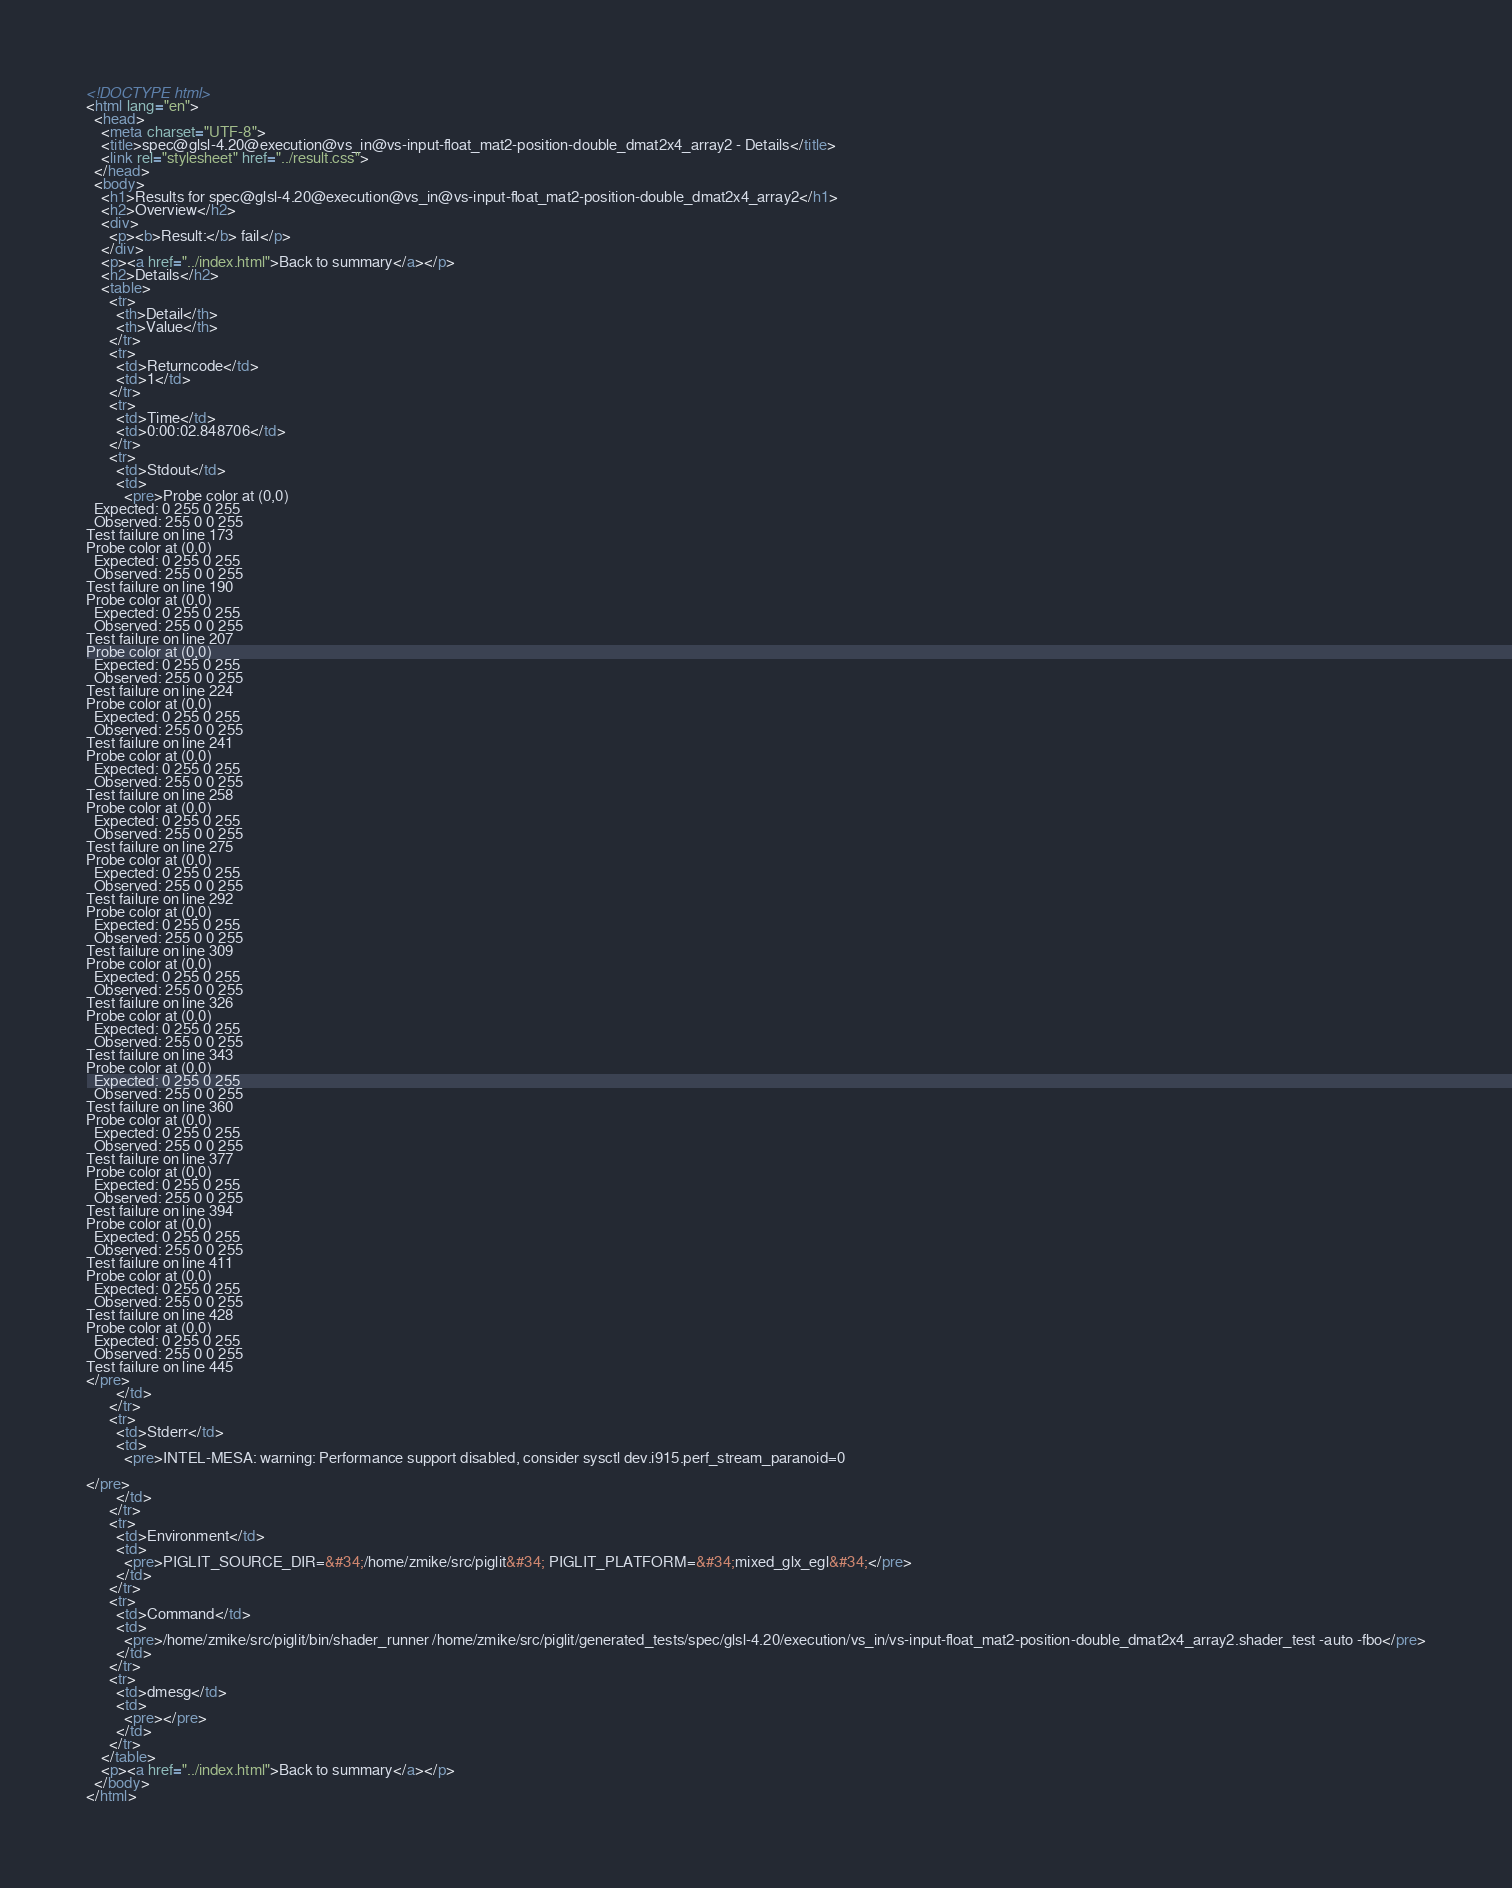Convert code to text. <code><loc_0><loc_0><loc_500><loc_500><_HTML_><!DOCTYPE html>
<html lang="en">
  <head>
    <meta charset="UTF-8">
    <title>spec@glsl-4.20@execution@vs_in@vs-input-float_mat2-position-double_dmat2x4_array2 - Details</title>
    <link rel="stylesheet" href="../result.css">
  </head>
  <body>
    <h1>Results for spec@glsl-4.20@execution@vs_in@vs-input-float_mat2-position-double_dmat2x4_array2</h1>
    <h2>Overview</h2>
    <div>
      <p><b>Result:</b> fail</p>
    </div>
    <p><a href="../index.html">Back to summary</a></p>
    <h2>Details</h2>
    <table>
      <tr>
        <th>Detail</th>
        <th>Value</th>
      </tr>
      <tr>
        <td>Returncode</td>
        <td>1</td>
      </tr>
      <tr>
        <td>Time</td>
        <td>0:00:02.848706</td>
      </tr>
      <tr>
        <td>Stdout</td>
        <td>
          <pre>Probe color at (0,0)
  Expected: 0 255 0 255
  Observed: 255 0 0 255
Test failure on line 173
Probe color at (0,0)
  Expected: 0 255 0 255
  Observed: 255 0 0 255
Test failure on line 190
Probe color at (0,0)
  Expected: 0 255 0 255
  Observed: 255 0 0 255
Test failure on line 207
Probe color at (0,0)
  Expected: 0 255 0 255
  Observed: 255 0 0 255
Test failure on line 224
Probe color at (0,0)
  Expected: 0 255 0 255
  Observed: 255 0 0 255
Test failure on line 241
Probe color at (0,0)
  Expected: 0 255 0 255
  Observed: 255 0 0 255
Test failure on line 258
Probe color at (0,0)
  Expected: 0 255 0 255
  Observed: 255 0 0 255
Test failure on line 275
Probe color at (0,0)
  Expected: 0 255 0 255
  Observed: 255 0 0 255
Test failure on line 292
Probe color at (0,0)
  Expected: 0 255 0 255
  Observed: 255 0 0 255
Test failure on line 309
Probe color at (0,0)
  Expected: 0 255 0 255
  Observed: 255 0 0 255
Test failure on line 326
Probe color at (0,0)
  Expected: 0 255 0 255
  Observed: 255 0 0 255
Test failure on line 343
Probe color at (0,0)
  Expected: 0 255 0 255
  Observed: 255 0 0 255
Test failure on line 360
Probe color at (0,0)
  Expected: 0 255 0 255
  Observed: 255 0 0 255
Test failure on line 377
Probe color at (0,0)
  Expected: 0 255 0 255
  Observed: 255 0 0 255
Test failure on line 394
Probe color at (0,0)
  Expected: 0 255 0 255
  Observed: 255 0 0 255
Test failure on line 411
Probe color at (0,0)
  Expected: 0 255 0 255
  Observed: 255 0 0 255
Test failure on line 428
Probe color at (0,0)
  Expected: 0 255 0 255
  Observed: 255 0 0 255
Test failure on line 445
</pre>
        </td>
      </tr>
      <tr>
        <td>Stderr</td>
        <td>
          <pre>INTEL-MESA: warning: Performance support disabled, consider sysctl dev.i915.perf_stream_paranoid=0

</pre>
        </td>
      </tr>
      <tr>
        <td>Environment</td>
        <td>
          <pre>PIGLIT_SOURCE_DIR=&#34;/home/zmike/src/piglit&#34; PIGLIT_PLATFORM=&#34;mixed_glx_egl&#34;</pre>
        </td>
      </tr>
      <tr>
        <td>Command</td>
        <td>
          <pre>/home/zmike/src/piglit/bin/shader_runner /home/zmike/src/piglit/generated_tests/spec/glsl-4.20/execution/vs_in/vs-input-float_mat2-position-double_dmat2x4_array2.shader_test -auto -fbo</pre>
        </td>
      </tr>
      <tr>
        <td>dmesg</td>
        <td>
          <pre></pre>
        </td>
      </tr>
    </table>
    <p><a href="../index.html">Back to summary</a></p>
  </body>
</html>
</code> 